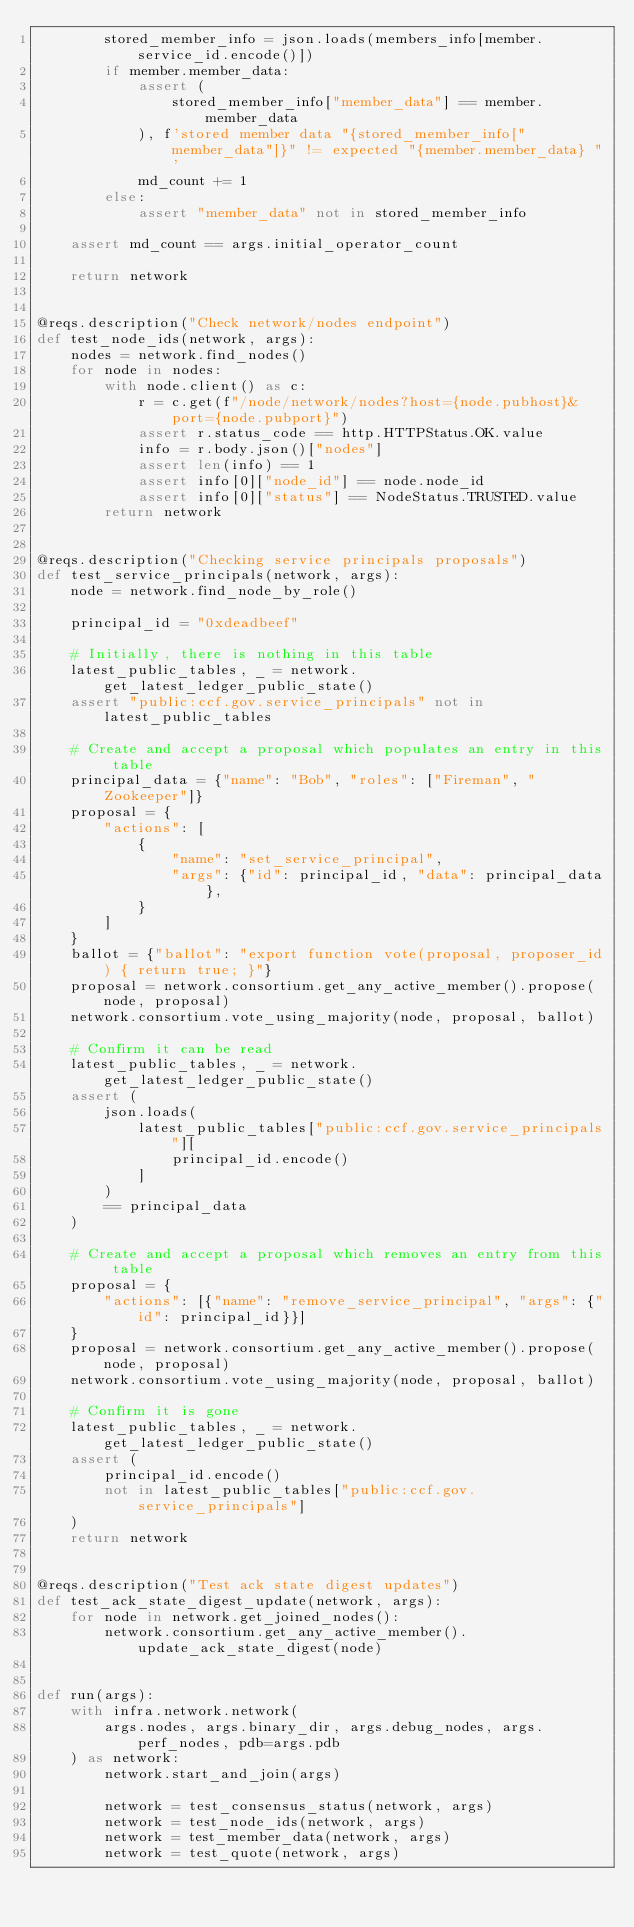<code> <loc_0><loc_0><loc_500><loc_500><_Python_>        stored_member_info = json.loads(members_info[member.service_id.encode()])
        if member.member_data:
            assert (
                stored_member_info["member_data"] == member.member_data
            ), f'stored member data "{stored_member_info["member_data"]}" != expected "{member.member_data} "'
            md_count += 1
        else:
            assert "member_data" not in stored_member_info

    assert md_count == args.initial_operator_count

    return network


@reqs.description("Check network/nodes endpoint")
def test_node_ids(network, args):
    nodes = network.find_nodes()
    for node in nodes:
        with node.client() as c:
            r = c.get(f"/node/network/nodes?host={node.pubhost}&port={node.pubport}")
            assert r.status_code == http.HTTPStatus.OK.value
            info = r.body.json()["nodes"]
            assert len(info) == 1
            assert info[0]["node_id"] == node.node_id
            assert info[0]["status"] == NodeStatus.TRUSTED.value
        return network


@reqs.description("Checking service principals proposals")
def test_service_principals(network, args):
    node = network.find_node_by_role()

    principal_id = "0xdeadbeef"

    # Initially, there is nothing in this table
    latest_public_tables, _ = network.get_latest_ledger_public_state()
    assert "public:ccf.gov.service_principals" not in latest_public_tables

    # Create and accept a proposal which populates an entry in this table
    principal_data = {"name": "Bob", "roles": ["Fireman", "Zookeeper"]}
    proposal = {
        "actions": [
            {
                "name": "set_service_principal",
                "args": {"id": principal_id, "data": principal_data},
            }
        ]
    }
    ballot = {"ballot": "export function vote(proposal, proposer_id) { return true; }"}
    proposal = network.consortium.get_any_active_member().propose(node, proposal)
    network.consortium.vote_using_majority(node, proposal, ballot)

    # Confirm it can be read
    latest_public_tables, _ = network.get_latest_ledger_public_state()
    assert (
        json.loads(
            latest_public_tables["public:ccf.gov.service_principals"][
                principal_id.encode()
            ]
        )
        == principal_data
    )

    # Create and accept a proposal which removes an entry from this table
    proposal = {
        "actions": [{"name": "remove_service_principal", "args": {"id": principal_id}}]
    }
    proposal = network.consortium.get_any_active_member().propose(node, proposal)
    network.consortium.vote_using_majority(node, proposal, ballot)

    # Confirm it is gone
    latest_public_tables, _ = network.get_latest_ledger_public_state()
    assert (
        principal_id.encode()
        not in latest_public_tables["public:ccf.gov.service_principals"]
    )
    return network


@reqs.description("Test ack state digest updates")
def test_ack_state_digest_update(network, args):
    for node in network.get_joined_nodes():
        network.consortium.get_any_active_member().update_ack_state_digest(node)


def run(args):
    with infra.network.network(
        args.nodes, args.binary_dir, args.debug_nodes, args.perf_nodes, pdb=args.pdb
    ) as network:
        network.start_and_join(args)

        network = test_consensus_status(network, args)
        network = test_node_ids(network, args)
        network = test_member_data(network, args)
        network = test_quote(network, args)</code> 